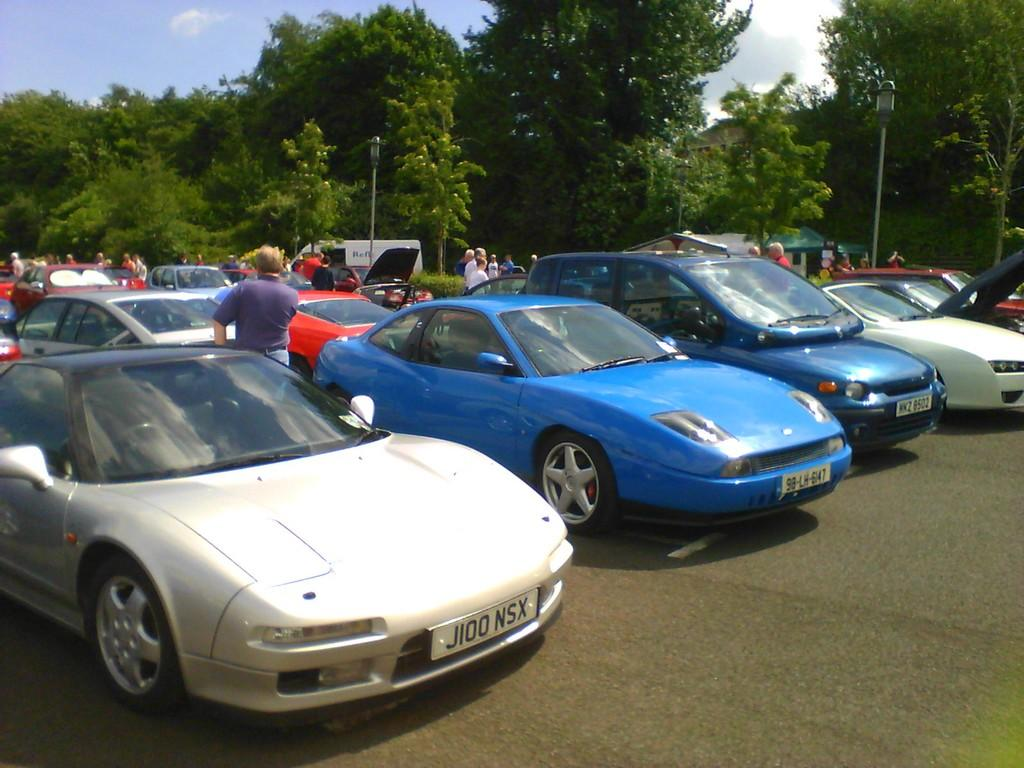What can be seen on the road in the image? There are cars on the road in the image. What else is present in the image besides the cars? There are people standing in the image. What can be seen in the background of the image? There are trees, poles, and the sky visible in the background of the image. What type of game is being played by the people in the image? There is no game being played in the image; people are simply standing. Can you describe the beast that is present in the image? There is no beast present in the image. 